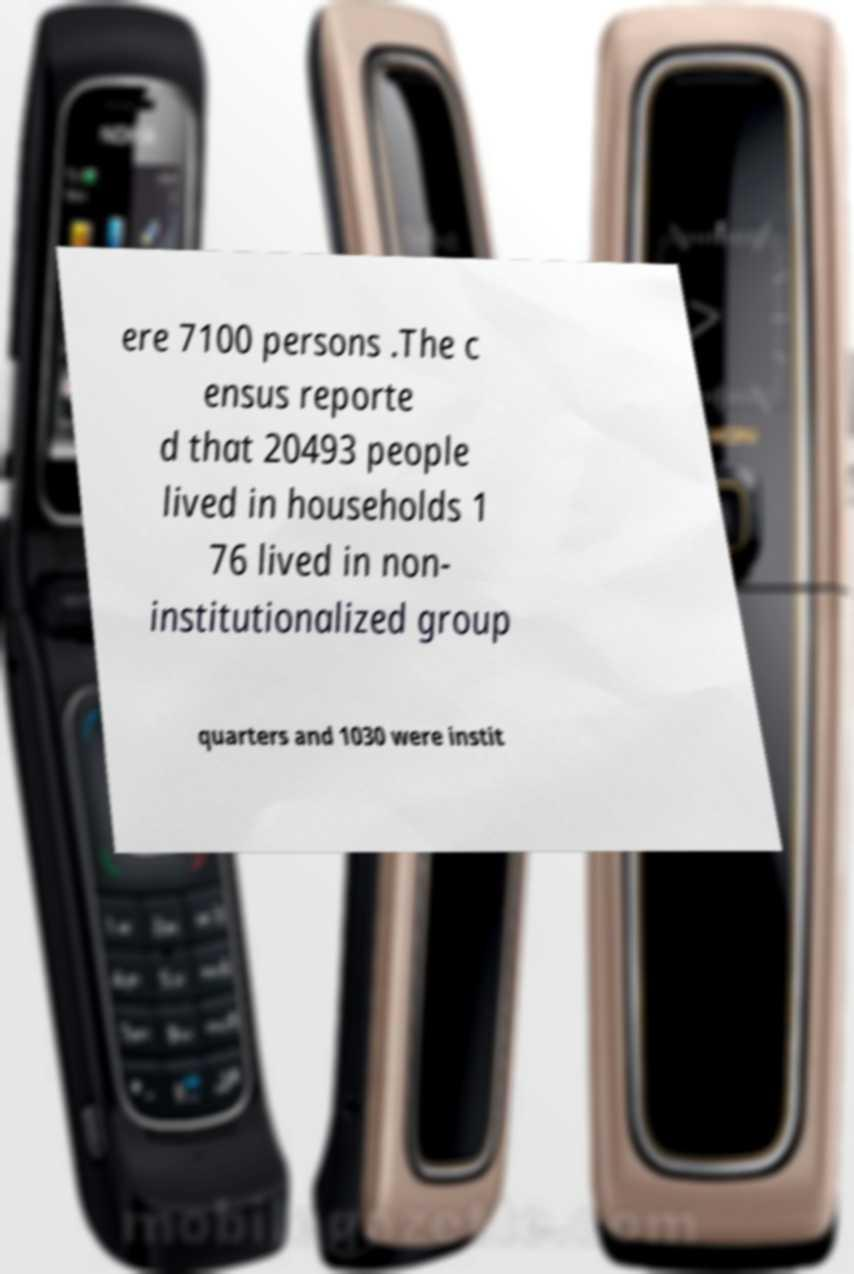Can you accurately transcribe the text from the provided image for me? ere 7100 persons .The c ensus reporte d that 20493 people lived in households 1 76 lived in non- institutionalized group quarters and 1030 were instit 